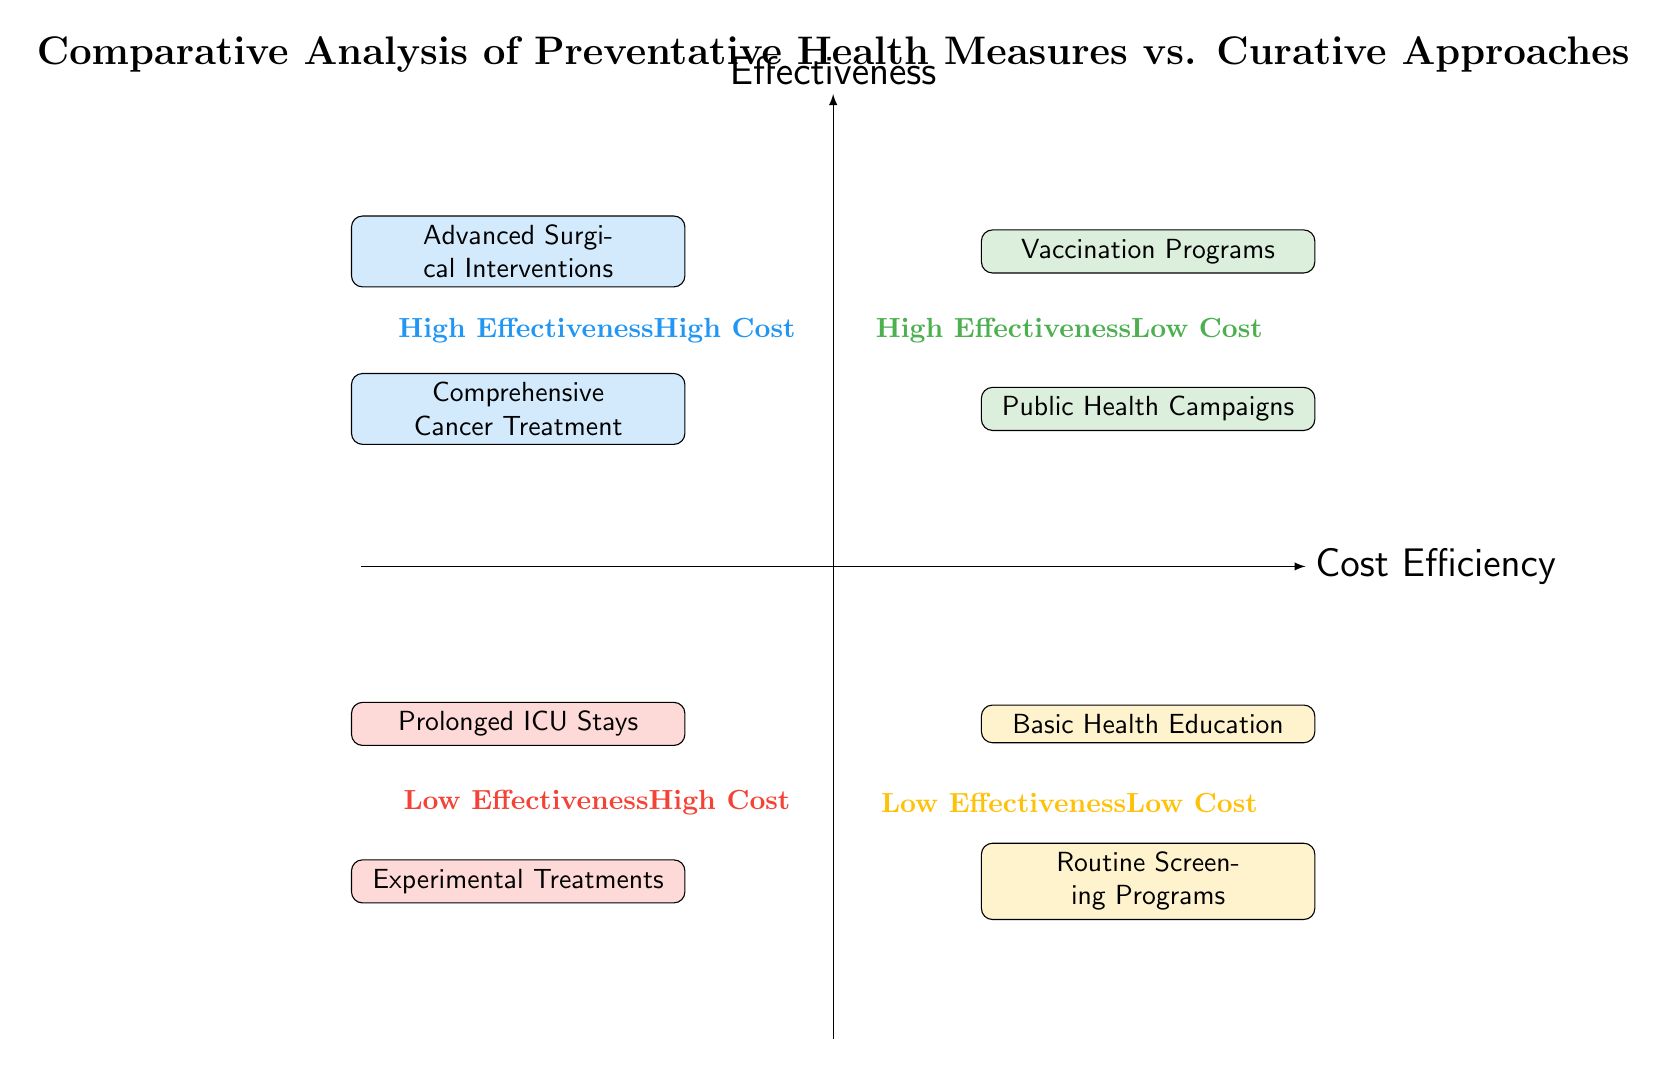What types of health measures are found in the High Effectiveness Low Cost quadrant? The High Effectiveness Low Cost quadrant contains two types of health measures: Vaccination Programs and Public Health Campaigns. These measures are both labeled under this quadrant, indicating they are effective and cost-efficient.
Answer: Vaccination Programs, Public Health Campaigns How many types of health measures are categorized as Low Effectiveness Low Cost? The Low Effectiveness Low Cost quadrant has two specific health measures listed: Basic Health Education and Routine Screening Programs. By counting the entries, we find that count equals two.
Answer: 2 Which health measure is considered High Effectiveness and High Cost? In the High Effectiveness High Cost quadrant, two health measures are listed: Advanced Surgical Interventions and Comprehensive Cancer Treatment. Thus, either entry serves as an answer.
Answer: Advanced Surgical Interventions, Comprehensive Cancer Treatment What is the only health measure in the Low Effectiveness High Cost quadrant? The Low Effectiveness High Cost quadrant contains two health measures, namely Prolonged ICU Stays and Experimental Treatments. Since there are two entries, the question asks for any single option, either works.
Answer: Prolonged ICU Stays, Experimental Treatments What is one example of a vaccination program? Both types of vaccination programs are listed under the High Effectiveness Low Cost quadrant, specifically examples stated include the Polio Eradication Initiative and the Covid-19 Vaccine Deployment. Any of these can be stated as an example.
Answer: Polio Eradication Initiative Which quadrant contains Basic Health Education? The Basic Health Education measure is positioned in the Low Effectiveness Low Cost quadrant, indicating it is not very effective but does require low costs. Thus, we can cite the location of this health measure.
Answer: Low Effectiveness Low Cost quadrant How does the effectiveness of Advanced Surgical Interventions compare to Routine Screening Programs? Advanced Surgical Interventions are placed in the High Effectiveness High Cost quadrant, while Routine Screening Programs are found in the Low Effectiveness Low Cost quadrant. Therefore, one has a high effectiveness while the other does not.
Answer: Advanced Surgical Interventions are higher in effectiveness Which public health initiative is recognized for its effectiveness and low costs? The Public Health Campaigns listed under the High Effectiveness Low Cost quadrant are cited as effective initiatives. These campaigns serve the dual purpose of being effective while not requiring significant funding.
Answer: Public Health Campaigns What does a high cost and low effectiveness signify in a healthcare context? The quadrant for Low Effectiveness High Cost represents measures that demand significant financial resources but provide minimal effectiveness. This denotes that such measures may not provide good returns on investment.
Answer: Prolonged ICU Stays, Experimental Treatments 